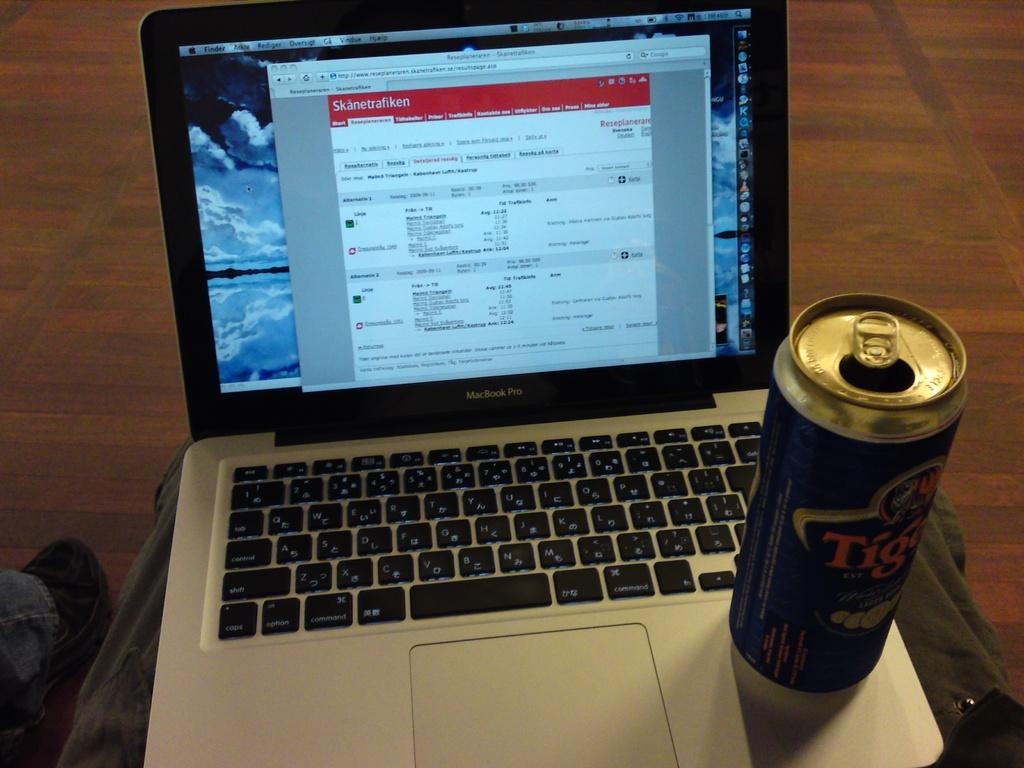Provide a one-sentence caption for the provided image. A macbook laptop with an opened can of a beverage. 